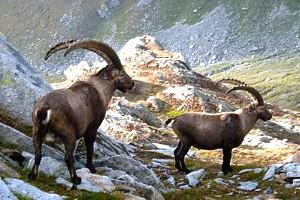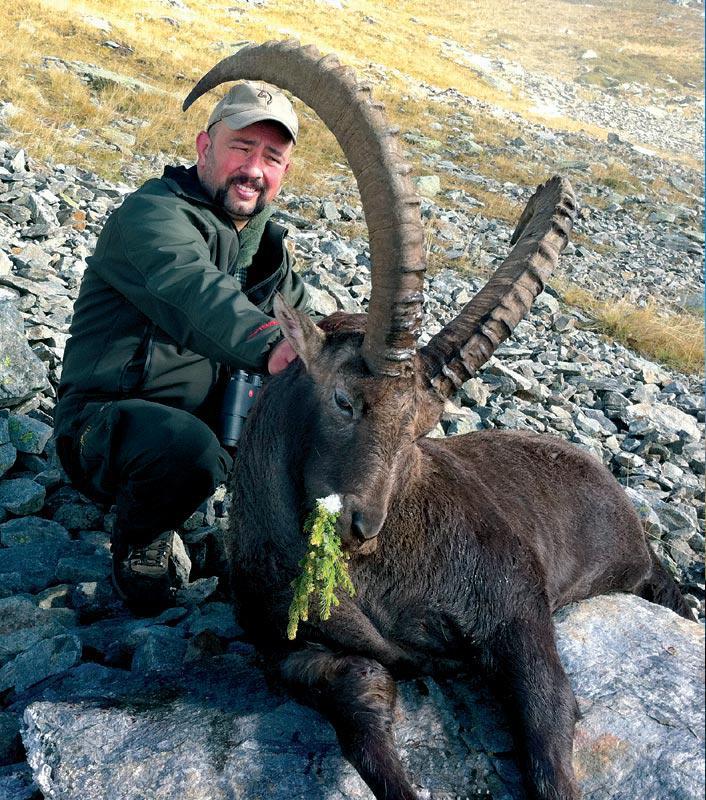The first image is the image on the left, the second image is the image on the right. For the images displayed, is the sentence "At least one person is posing with a horned animal in one of the pictures." factually correct? Answer yes or no. Yes. The first image is the image on the left, the second image is the image on the right. Examine the images to the left and right. Is the description "At least one man is posed behind a downed long-horned animal in one image." accurate? Answer yes or no. Yes. 